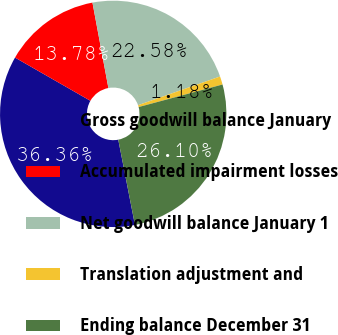Convert chart to OTSL. <chart><loc_0><loc_0><loc_500><loc_500><pie_chart><fcel>Gross goodwill balance January<fcel>Accumulated impairment losses<fcel>Net goodwill balance January 1<fcel>Translation adjustment and<fcel>Ending balance December 31<nl><fcel>36.36%<fcel>13.78%<fcel>22.58%<fcel>1.18%<fcel>26.1%<nl></chart> 